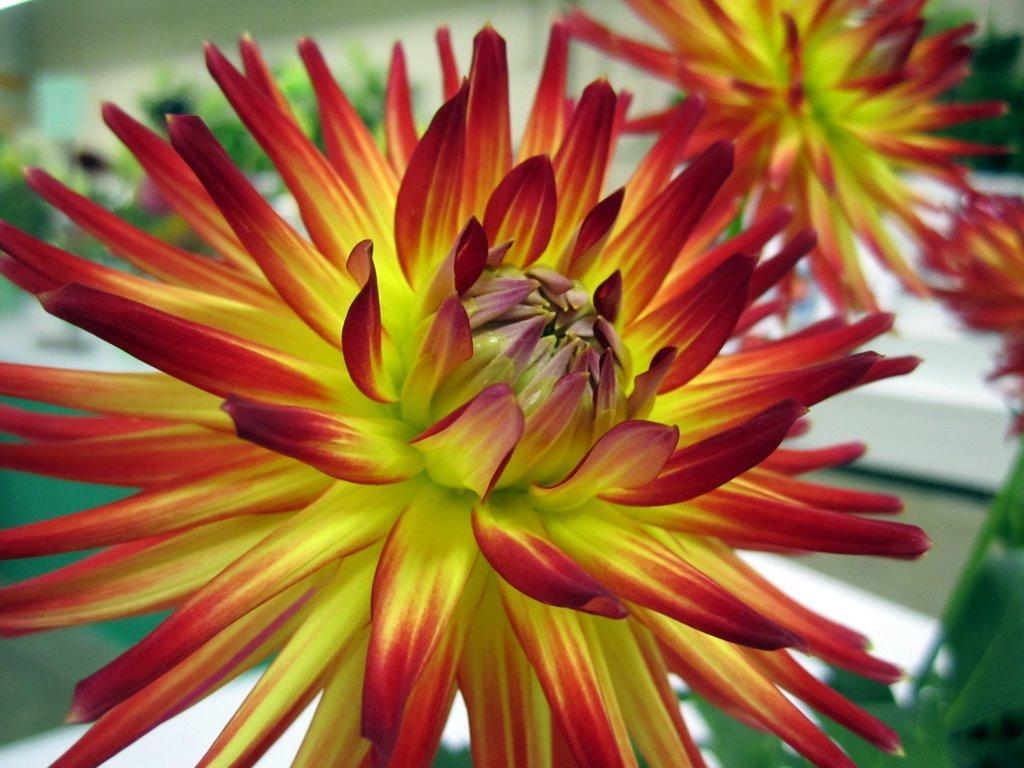Describe this image in one or two sentences. In this picture we can observe yellow and red color flowers. The background is completely blurred. 